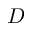<formula> <loc_0><loc_0><loc_500><loc_500>D</formula> 